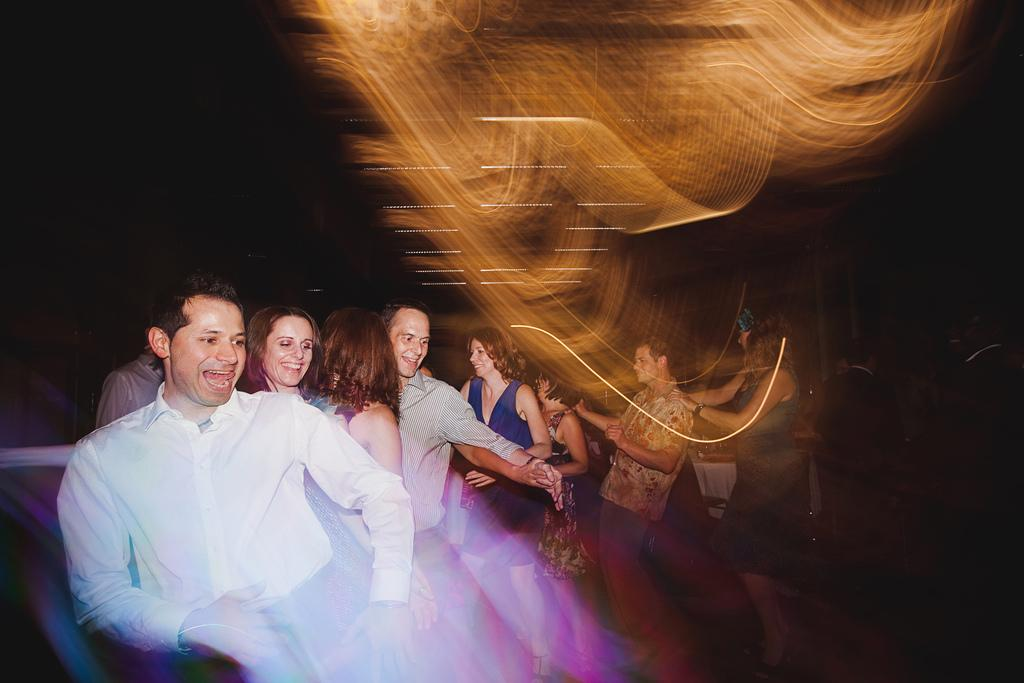What are the people in the image doing? The people in the image are dancing. Can you describe the background of the image? The background of the image is dark. What effect does the turkey have on the group in the image? There is no turkey present in the image, so it cannot have any effect on the group. 